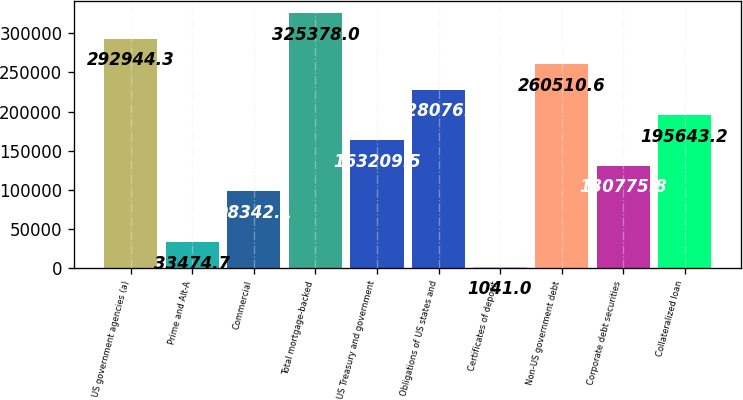Convert chart. <chart><loc_0><loc_0><loc_500><loc_500><bar_chart><fcel>US government agencies (a)<fcel>Prime and Alt-A<fcel>Commercial<fcel>Total mortgage-backed<fcel>US Treasury and government<fcel>Obligations of US states and<fcel>Certificates of deposit<fcel>Non-US government debt<fcel>Corporate debt securities<fcel>Collateralized loan<nl><fcel>292944<fcel>33474.7<fcel>98342.1<fcel>325378<fcel>163210<fcel>228077<fcel>1041<fcel>260511<fcel>130776<fcel>195643<nl></chart> 